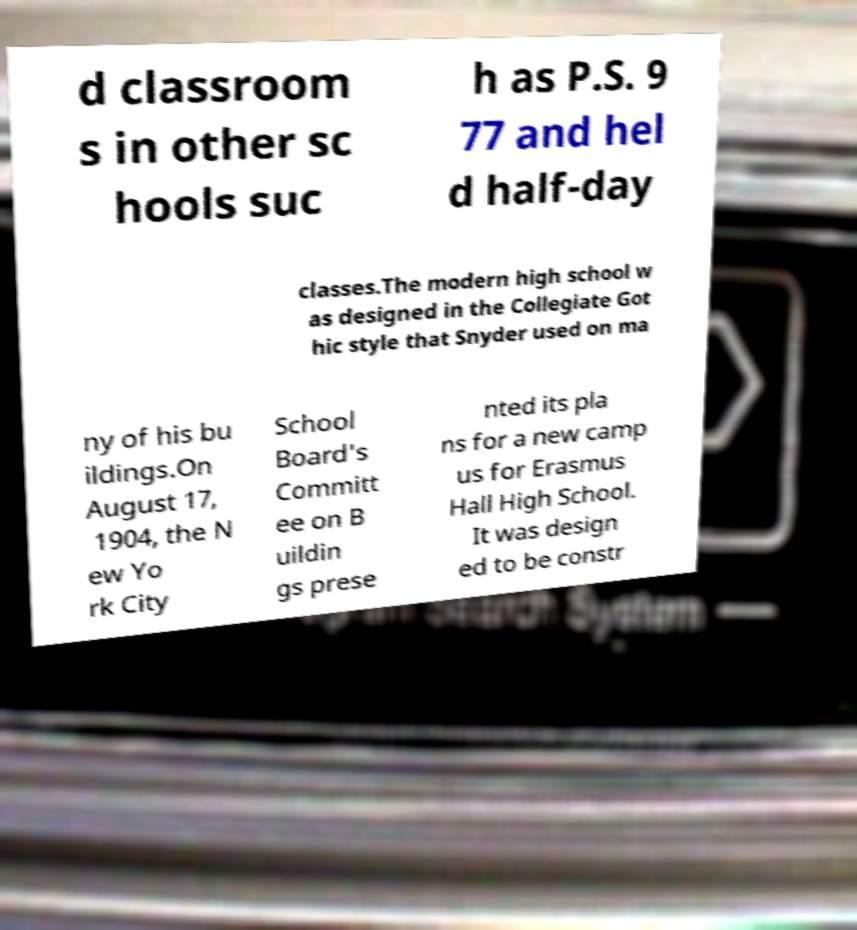Can you read and provide the text displayed in the image?This photo seems to have some interesting text. Can you extract and type it out for me? d classroom s in other sc hools suc h as P.S. 9 77 and hel d half-day classes.The modern high school w as designed in the Collegiate Got hic style that Snyder used on ma ny of his bu ildings.On August 17, 1904, the N ew Yo rk City School Board's Committ ee on B uildin gs prese nted its pla ns for a new camp us for Erasmus Hall High School. It was design ed to be constr 